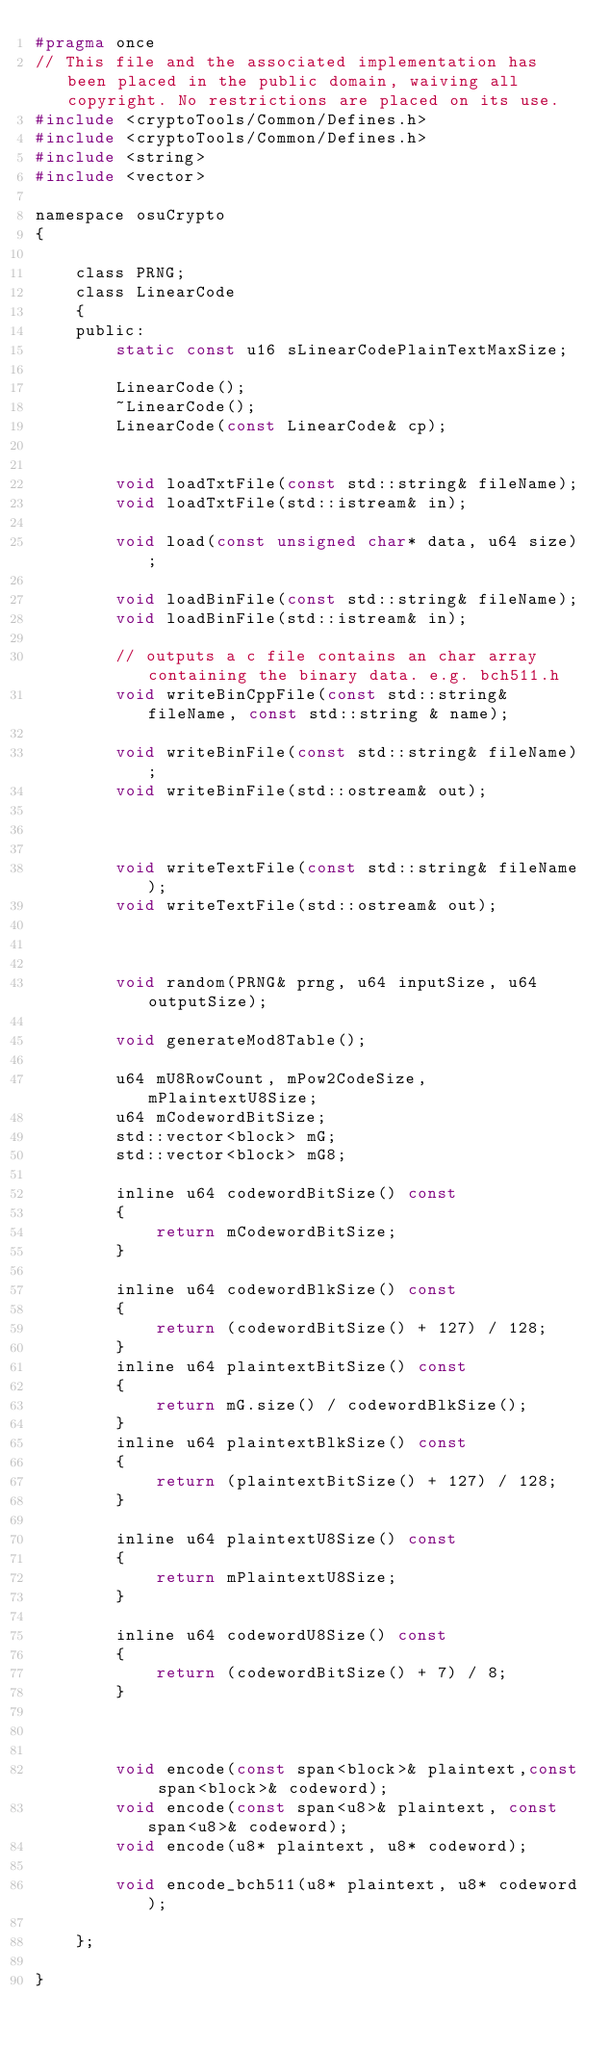Convert code to text. <code><loc_0><loc_0><loc_500><loc_500><_C_>#pragma once
// This file and the associated implementation has been placed in the public domain, waiving all copyright. No restrictions are placed on its use. 
#include <cryptoTools/Common/Defines.h>
#include <cryptoTools/Common/Defines.h>
#include <string>
#include <vector>

namespace osuCrypto
{

    class PRNG;
    class LinearCode
    {
    public:
        static const u16 sLinearCodePlainTextMaxSize;

        LinearCode();
        ~LinearCode();
        LinearCode(const LinearCode& cp);


        void loadTxtFile(const std::string& fileName);
        void loadTxtFile(std::istream& in);

        void load(const unsigned char* data, u64 size);

        void loadBinFile(const std::string& fileName);
        void loadBinFile(std::istream& in);

        // outputs a c file contains an char array containing the binary data. e.g. bch511.h
        void writeBinCppFile(const std::string& fileName, const std::string & name);

        void writeBinFile(const std::string& fileName);
        void writeBinFile(std::ostream& out);



        void writeTextFile(const std::string& fileName);
        void writeTextFile(std::ostream& out);



        void random(PRNG& prng, u64 inputSize, u64 outputSize);

        void generateMod8Table();

        u64 mU8RowCount, mPow2CodeSize, mPlaintextU8Size;
        u64 mCodewordBitSize;
        std::vector<block> mG;
        std::vector<block> mG8;

        inline u64 codewordBitSize() const
        {
            return mCodewordBitSize;
        }

        inline u64 codewordBlkSize() const
        {
            return (codewordBitSize() + 127) / 128;
        }
        inline u64 plaintextBitSize() const
        {
            return mG.size() / codewordBlkSize();
        }
        inline u64 plaintextBlkSize() const
        {
            return (plaintextBitSize() + 127) / 128;
        }

        inline u64 plaintextU8Size() const
        {
            return mPlaintextU8Size;
        }

        inline u64 codewordU8Size() const
        {
            return (codewordBitSize() + 7) / 8;
        }



        void encode(const span<block>& plaintext,const span<block>& codeword);
        void encode(const span<u8>& plaintext, const span<u8>& codeword);
        void encode(u8* plaintext, u8* codeword);

        void encode_bch511(u8* plaintext, u8* codeword);

    };

}
</code> 